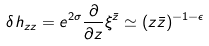<formula> <loc_0><loc_0><loc_500><loc_500>\delta h _ { z z } = e ^ { 2 \sigma } \frac { \partial } { \partial z } \xi ^ { \bar { z } } \simeq ( z \bar { z } ) ^ { - 1 - \epsilon }</formula> 